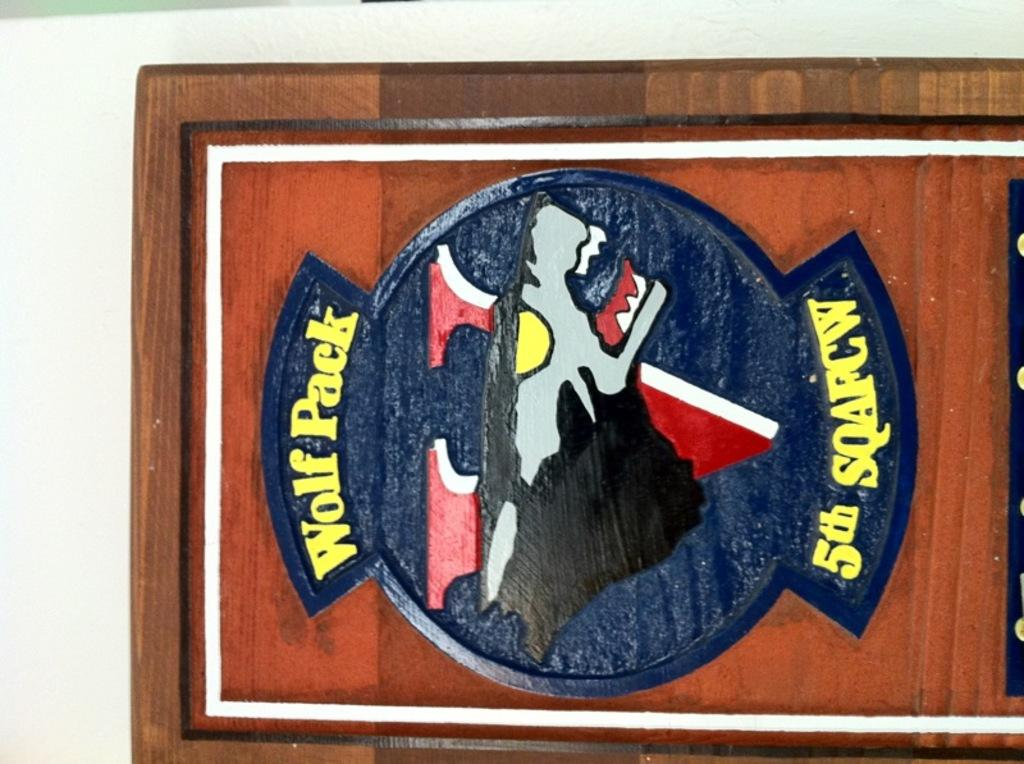<image>
Describe the image concisely. A framed poster for Wolf Pack 5th SQAFW. 